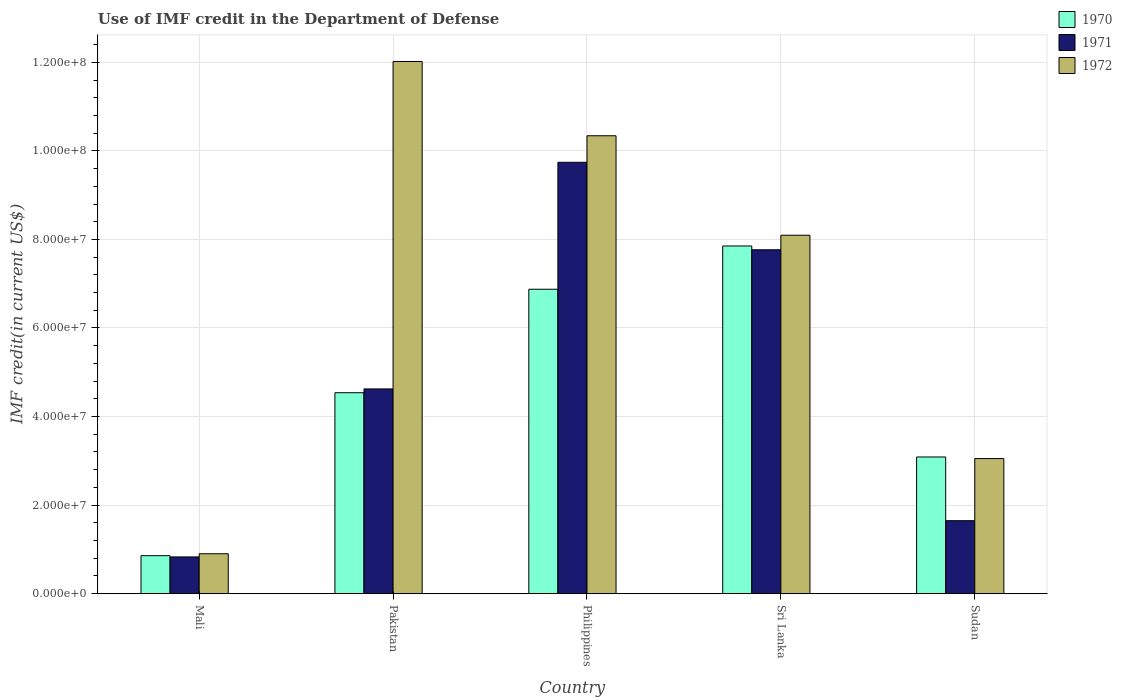How many different coloured bars are there?
Keep it short and to the point. 3. How many groups of bars are there?
Provide a short and direct response. 5. Are the number of bars per tick equal to the number of legend labels?
Provide a succinct answer. Yes. Are the number of bars on each tick of the X-axis equal?
Your response must be concise. Yes. How many bars are there on the 5th tick from the left?
Your answer should be very brief. 3. What is the label of the 2nd group of bars from the left?
Offer a terse response. Pakistan. What is the IMF credit in the Department of Defense in 1971 in Pakistan?
Provide a short and direct response. 4.62e+07. Across all countries, what is the maximum IMF credit in the Department of Defense in 1971?
Your response must be concise. 9.74e+07. Across all countries, what is the minimum IMF credit in the Department of Defense in 1971?
Offer a terse response. 8.30e+06. In which country was the IMF credit in the Department of Defense in 1970 maximum?
Your answer should be very brief. Sri Lanka. In which country was the IMF credit in the Department of Defense in 1971 minimum?
Offer a very short reply. Mali. What is the total IMF credit in the Department of Defense in 1971 in the graph?
Your answer should be compact. 2.46e+08. What is the difference between the IMF credit in the Department of Defense in 1972 in Mali and that in Sri Lanka?
Give a very brief answer. -7.19e+07. What is the difference between the IMF credit in the Department of Defense in 1971 in Sri Lanka and the IMF credit in the Department of Defense in 1972 in Mali?
Your answer should be very brief. 6.87e+07. What is the average IMF credit in the Department of Defense in 1971 per country?
Keep it short and to the point. 4.92e+07. What is the difference between the IMF credit in the Department of Defense of/in 1971 and IMF credit in the Department of Defense of/in 1970 in Sri Lanka?
Offer a very short reply. -8.56e+05. What is the ratio of the IMF credit in the Department of Defense in 1971 in Pakistan to that in Sri Lanka?
Your response must be concise. 0.6. Is the difference between the IMF credit in the Department of Defense in 1971 in Mali and Philippines greater than the difference between the IMF credit in the Department of Defense in 1970 in Mali and Philippines?
Offer a terse response. No. What is the difference between the highest and the second highest IMF credit in the Department of Defense in 1972?
Your answer should be compact. 1.68e+07. What is the difference between the highest and the lowest IMF credit in the Department of Defense in 1970?
Your answer should be very brief. 6.99e+07. In how many countries, is the IMF credit in the Department of Defense in 1971 greater than the average IMF credit in the Department of Defense in 1971 taken over all countries?
Your answer should be compact. 2. Is the sum of the IMF credit in the Department of Defense in 1970 in Mali and Philippines greater than the maximum IMF credit in the Department of Defense in 1972 across all countries?
Give a very brief answer. No. Is it the case that in every country, the sum of the IMF credit in the Department of Defense in 1970 and IMF credit in the Department of Defense in 1971 is greater than the IMF credit in the Department of Defense in 1972?
Offer a terse response. No. Are all the bars in the graph horizontal?
Give a very brief answer. No. How many countries are there in the graph?
Your answer should be very brief. 5. Does the graph contain any zero values?
Make the answer very short. No. Does the graph contain grids?
Make the answer very short. Yes. How many legend labels are there?
Your answer should be very brief. 3. How are the legend labels stacked?
Your response must be concise. Vertical. What is the title of the graph?
Keep it short and to the point. Use of IMF credit in the Department of Defense. What is the label or title of the X-axis?
Ensure brevity in your answer.  Country. What is the label or title of the Y-axis?
Your answer should be compact. IMF credit(in current US$). What is the IMF credit(in current US$) of 1970 in Mali?
Your response must be concise. 8.58e+06. What is the IMF credit(in current US$) in 1971 in Mali?
Give a very brief answer. 8.30e+06. What is the IMF credit(in current US$) in 1972 in Mali?
Provide a short and direct response. 9.01e+06. What is the IMF credit(in current US$) of 1970 in Pakistan?
Provide a succinct answer. 4.54e+07. What is the IMF credit(in current US$) of 1971 in Pakistan?
Your response must be concise. 4.62e+07. What is the IMF credit(in current US$) in 1972 in Pakistan?
Provide a succinct answer. 1.20e+08. What is the IMF credit(in current US$) in 1970 in Philippines?
Provide a short and direct response. 6.88e+07. What is the IMF credit(in current US$) of 1971 in Philippines?
Make the answer very short. 9.74e+07. What is the IMF credit(in current US$) of 1972 in Philippines?
Ensure brevity in your answer.  1.03e+08. What is the IMF credit(in current US$) of 1970 in Sri Lanka?
Make the answer very short. 7.85e+07. What is the IMF credit(in current US$) of 1971 in Sri Lanka?
Provide a short and direct response. 7.77e+07. What is the IMF credit(in current US$) in 1972 in Sri Lanka?
Offer a very short reply. 8.10e+07. What is the IMF credit(in current US$) in 1970 in Sudan?
Provide a succinct answer. 3.09e+07. What is the IMF credit(in current US$) in 1971 in Sudan?
Provide a short and direct response. 1.65e+07. What is the IMF credit(in current US$) in 1972 in Sudan?
Offer a very short reply. 3.05e+07. Across all countries, what is the maximum IMF credit(in current US$) of 1970?
Your response must be concise. 7.85e+07. Across all countries, what is the maximum IMF credit(in current US$) of 1971?
Your answer should be compact. 9.74e+07. Across all countries, what is the maximum IMF credit(in current US$) of 1972?
Provide a short and direct response. 1.20e+08. Across all countries, what is the minimum IMF credit(in current US$) in 1970?
Provide a short and direct response. 8.58e+06. Across all countries, what is the minimum IMF credit(in current US$) of 1971?
Your response must be concise. 8.30e+06. Across all countries, what is the minimum IMF credit(in current US$) in 1972?
Provide a short and direct response. 9.01e+06. What is the total IMF credit(in current US$) of 1970 in the graph?
Make the answer very short. 2.32e+08. What is the total IMF credit(in current US$) of 1971 in the graph?
Your answer should be compact. 2.46e+08. What is the total IMF credit(in current US$) of 1972 in the graph?
Offer a very short reply. 3.44e+08. What is the difference between the IMF credit(in current US$) in 1970 in Mali and that in Pakistan?
Provide a short and direct response. -3.68e+07. What is the difference between the IMF credit(in current US$) of 1971 in Mali and that in Pakistan?
Your answer should be very brief. -3.79e+07. What is the difference between the IMF credit(in current US$) of 1972 in Mali and that in Pakistan?
Keep it short and to the point. -1.11e+08. What is the difference between the IMF credit(in current US$) of 1970 in Mali and that in Philippines?
Keep it short and to the point. -6.02e+07. What is the difference between the IMF credit(in current US$) in 1971 in Mali and that in Philippines?
Your answer should be compact. -8.91e+07. What is the difference between the IMF credit(in current US$) in 1972 in Mali and that in Philippines?
Offer a terse response. -9.44e+07. What is the difference between the IMF credit(in current US$) in 1970 in Mali and that in Sri Lanka?
Your answer should be compact. -6.99e+07. What is the difference between the IMF credit(in current US$) in 1971 in Mali and that in Sri Lanka?
Offer a terse response. -6.94e+07. What is the difference between the IMF credit(in current US$) of 1972 in Mali and that in Sri Lanka?
Keep it short and to the point. -7.19e+07. What is the difference between the IMF credit(in current US$) in 1970 in Mali and that in Sudan?
Keep it short and to the point. -2.23e+07. What is the difference between the IMF credit(in current US$) in 1971 in Mali and that in Sudan?
Keep it short and to the point. -8.19e+06. What is the difference between the IMF credit(in current US$) in 1972 in Mali and that in Sudan?
Your answer should be compact. -2.15e+07. What is the difference between the IMF credit(in current US$) in 1970 in Pakistan and that in Philippines?
Your answer should be very brief. -2.34e+07. What is the difference between the IMF credit(in current US$) in 1971 in Pakistan and that in Philippines?
Give a very brief answer. -5.12e+07. What is the difference between the IMF credit(in current US$) of 1972 in Pakistan and that in Philippines?
Your answer should be very brief. 1.68e+07. What is the difference between the IMF credit(in current US$) of 1970 in Pakistan and that in Sri Lanka?
Ensure brevity in your answer.  -3.31e+07. What is the difference between the IMF credit(in current US$) in 1971 in Pakistan and that in Sri Lanka?
Provide a short and direct response. -3.14e+07. What is the difference between the IMF credit(in current US$) of 1972 in Pakistan and that in Sri Lanka?
Make the answer very short. 3.92e+07. What is the difference between the IMF credit(in current US$) in 1970 in Pakistan and that in Sudan?
Provide a succinct answer. 1.45e+07. What is the difference between the IMF credit(in current US$) of 1971 in Pakistan and that in Sudan?
Ensure brevity in your answer.  2.98e+07. What is the difference between the IMF credit(in current US$) in 1972 in Pakistan and that in Sudan?
Provide a short and direct response. 8.97e+07. What is the difference between the IMF credit(in current US$) in 1970 in Philippines and that in Sri Lanka?
Provide a succinct answer. -9.77e+06. What is the difference between the IMF credit(in current US$) in 1971 in Philippines and that in Sri Lanka?
Make the answer very short. 1.98e+07. What is the difference between the IMF credit(in current US$) in 1972 in Philippines and that in Sri Lanka?
Make the answer very short. 2.25e+07. What is the difference between the IMF credit(in current US$) of 1970 in Philippines and that in Sudan?
Provide a short and direct response. 3.79e+07. What is the difference between the IMF credit(in current US$) of 1971 in Philippines and that in Sudan?
Ensure brevity in your answer.  8.09e+07. What is the difference between the IMF credit(in current US$) of 1972 in Philippines and that in Sudan?
Offer a terse response. 7.29e+07. What is the difference between the IMF credit(in current US$) of 1970 in Sri Lanka and that in Sudan?
Your answer should be very brief. 4.76e+07. What is the difference between the IMF credit(in current US$) in 1971 in Sri Lanka and that in Sudan?
Your answer should be very brief. 6.12e+07. What is the difference between the IMF credit(in current US$) of 1972 in Sri Lanka and that in Sudan?
Offer a very short reply. 5.04e+07. What is the difference between the IMF credit(in current US$) of 1970 in Mali and the IMF credit(in current US$) of 1971 in Pakistan?
Provide a short and direct response. -3.77e+07. What is the difference between the IMF credit(in current US$) of 1970 in Mali and the IMF credit(in current US$) of 1972 in Pakistan?
Your answer should be very brief. -1.12e+08. What is the difference between the IMF credit(in current US$) of 1971 in Mali and the IMF credit(in current US$) of 1972 in Pakistan?
Make the answer very short. -1.12e+08. What is the difference between the IMF credit(in current US$) in 1970 in Mali and the IMF credit(in current US$) in 1971 in Philippines?
Your answer should be compact. -8.88e+07. What is the difference between the IMF credit(in current US$) in 1970 in Mali and the IMF credit(in current US$) in 1972 in Philippines?
Your answer should be compact. -9.48e+07. What is the difference between the IMF credit(in current US$) of 1971 in Mali and the IMF credit(in current US$) of 1972 in Philippines?
Your response must be concise. -9.51e+07. What is the difference between the IMF credit(in current US$) in 1970 in Mali and the IMF credit(in current US$) in 1971 in Sri Lanka?
Provide a short and direct response. -6.91e+07. What is the difference between the IMF credit(in current US$) in 1970 in Mali and the IMF credit(in current US$) in 1972 in Sri Lanka?
Your answer should be very brief. -7.24e+07. What is the difference between the IMF credit(in current US$) of 1971 in Mali and the IMF credit(in current US$) of 1972 in Sri Lanka?
Provide a short and direct response. -7.27e+07. What is the difference between the IMF credit(in current US$) in 1970 in Mali and the IMF credit(in current US$) in 1971 in Sudan?
Your answer should be compact. -7.90e+06. What is the difference between the IMF credit(in current US$) in 1970 in Mali and the IMF credit(in current US$) in 1972 in Sudan?
Your answer should be compact. -2.19e+07. What is the difference between the IMF credit(in current US$) of 1971 in Mali and the IMF credit(in current US$) of 1972 in Sudan?
Make the answer very short. -2.22e+07. What is the difference between the IMF credit(in current US$) in 1970 in Pakistan and the IMF credit(in current US$) in 1971 in Philippines?
Your answer should be compact. -5.20e+07. What is the difference between the IMF credit(in current US$) of 1970 in Pakistan and the IMF credit(in current US$) of 1972 in Philippines?
Keep it short and to the point. -5.80e+07. What is the difference between the IMF credit(in current US$) of 1971 in Pakistan and the IMF credit(in current US$) of 1972 in Philippines?
Give a very brief answer. -5.72e+07. What is the difference between the IMF credit(in current US$) in 1970 in Pakistan and the IMF credit(in current US$) in 1971 in Sri Lanka?
Keep it short and to the point. -3.23e+07. What is the difference between the IMF credit(in current US$) in 1970 in Pakistan and the IMF credit(in current US$) in 1972 in Sri Lanka?
Your answer should be compact. -3.56e+07. What is the difference between the IMF credit(in current US$) of 1971 in Pakistan and the IMF credit(in current US$) of 1972 in Sri Lanka?
Offer a terse response. -3.47e+07. What is the difference between the IMF credit(in current US$) in 1970 in Pakistan and the IMF credit(in current US$) in 1971 in Sudan?
Your answer should be compact. 2.89e+07. What is the difference between the IMF credit(in current US$) in 1970 in Pakistan and the IMF credit(in current US$) in 1972 in Sudan?
Your answer should be very brief. 1.49e+07. What is the difference between the IMF credit(in current US$) in 1971 in Pakistan and the IMF credit(in current US$) in 1972 in Sudan?
Offer a terse response. 1.57e+07. What is the difference between the IMF credit(in current US$) of 1970 in Philippines and the IMF credit(in current US$) of 1971 in Sri Lanka?
Your answer should be very brief. -8.91e+06. What is the difference between the IMF credit(in current US$) in 1970 in Philippines and the IMF credit(in current US$) in 1972 in Sri Lanka?
Make the answer very short. -1.22e+07. What is the difference between the IMF credit(in current US$) of 1971 in Philippines and the IMF credit(in current US$) of 1972 in Sri Lanka?
Keep it short and to the point. 1.65e+07. What is the difference between the IMF credit(in current US$) in 1970 in Philippines and the IMF credit(in current US$) in 1971 in Sudan?
Your response must be concise. 5.23e+07. What is the difference between the IMF credit(in current US$) of 1970 in Philippines and the IMF credit(in current US$) of 1972 in Sudan?
Your response must be concise. 3.82e+07. What is the difference between the IMF credit(in current US$) in 1971 in Philippines and the IMF credit(in current US$) in 1972 in Sudan?
Your answer should be compact. 6.69e+07. What is the difference between the IMF credit(in current US$) in 1970 in Sri Lanka and the IMF credit(in current US$) in 1971 in Sudan?
Offer a terse response. 6.20e+07. What is the difference between the IMF credit(in current US$) of 1970 in Sri Lanka and the IMF credit(in current US$) of 1972 in Sudan?
Provide a succinct answer. 4.80e+07. What is the difference between the IMF credit(in current US$) of 1971 in Sri Lanka and the IMF credit(in current US$) of 1972 in Sudan?
Provide a succinct answer. 4.72e+07. What is the average IMF credit(in current US$) of 1970 per country?
Keep it short and to the point. 4.64e+07. What is the average IMF credit(in current US$) of 1971 per country?
Your answer should be very brief. 4.92e+07. What is the average IMF credit(in current US$) in 1972 per country?
Provide a succinct answer. 6.88e+07. What is the difference between the IMF credit(in current US$) of 1970 and IMF credit(in current US$) of 1971 in Mali?
Give a very brief answer. 2.85e+05. What is the difference between the IMF credit(in current US$) of 1970 and IMF credit(in current US$) of 1972 in Mali?
Your response must be concise. -4.31e+05. What is the difference between the IMF credit(in current US$) of 1971 and IMF credit(in current US$) of 1972 in Mali?
Your response must be concise. -7.16e+05. What is the difference between the IMF credit(in current US$) in 1970 and IMF credit(in current US$) in 1971 in Pakistan?
Give a very brief answer. -8.56e+05. What is the difference between the IMF credit(in current US$) in 1970 and IMF credit(in current US$) in 1972 in Pakistan?
Keep it short and to the point. -7.48e+07. What is the difference between the IMF credit(in current US$) in 1971 and IMF credit(in current US$) in 1972 in Pakistan?
Give a very brief answer. -7.40e+07. What is the difference between the IMF credit(in current US$) of 1970 and IMF credit(in current US$) of 1971 in Philippines?
Offer a very short reply. -2.87e+07. What is the difference between the IMF credit(in current US$) of 1970 and IMF credit(in current US$) of 1972 in Philippines?
Offer a very short reply. -3.47e+07. What is the difference between the IMF credit(in current US$) in 1971 and IMF credit(in current US$) in 1972 in Philippines?
Your answer should be compact. -5.99e+06. What is the difference between the IMF credit(in current US$) of 1970 and IMF credit(in current US$) of 1971 in Sri Lanka?
Your answer should be very brief. 8.56e+05. What is the difference between the IMF credit(in current US$) of 1970 and IMF credit(in current US$) of 1972 in Sri Lanka?
Your answer should be compact. -2.43e+06. What is the difference between the IMF credit(in current US$) of 1971 and IMF credit(in current US$) of 1972 in Sri Lanka?
Offer a very short reply. -3.29e+06. What is the difference between the IMF credit(in current US$) in 1970 and IMF credit(in current US$) in 1971 in Sudan?
Provide a short and direct response. 1.44e+07. What is the difference between the IMF credit(in current US$) in 1970 and IMF credit(in current US$) in 1972 in Sudan?
Keep it short and to the point. 3.62e+05. What is the difference between the IMF credit(in current US$) of 1971 and IMF credit(in current US$) of 1972 in Sudan?
Offer a very short reply. -1.40e+07. What is the ratio of the IMF credit(in current US$) of 1970 in Mali to that in Pakistan?
Make the answer very short. 0.19. What is the ratio of the IMF credit(in current US$) of 1971 in Mali to that in Pakistan?
Offer a very short reply. 0.18. What is the ratio of the IMF credit(in current US$) in 1972 in Mali to that in Pakistan?
Your answer should be very brief. 0.07. What is the ratio of the IMF credit(in current US$) in 1970 in Mali to that in Philippines?
Offer a terse response. 0.12. What is the ratio of the IMF credit(in current US$) of 1971 in Mali to that in Philippines?
Make the answer very short. 0.09. What is the ratio of the IMF credit(in current US$) in 1972 in Mali to that in Philippines?
Make the answer very short. 0.09. What is the ratio of the IMF credit(in current US$) of 1970 in Mali to that in Sri Lanka?
Ensure brevity in your answer.  0.11. What is the ratio of the IMF credit(in current US$) of 1971 in Mali to that in Sri Lanka?
Provide a short and direct response. 0.11. What is the ratio of the IMF credit(in current US$) of 1972 in Mali to that in Sri Lanka?
Give a very brief answer. 0.11. What is the ratio of the IMF credit(in current US$) of 1970 in Mali to that in Sudan?
Give a very brief answer. 0.28. What is the ratio of the IMF credit(in current US$) of 1971 in Mali to that in Sudan?
Your answer should be very brief. 0.5. What is the ratio of the IMF credit(in current US$) of 1972 in Mali to that in Sudan?
Ensure brevity in your answer.  0.3. What is the ratio of the IMF credit(in current US$) of 1970 in Pakistan to that in Philippines?
Offer a very short reply. 0.66. What is the ratio of the IMF credit(in current US$) of 1971 in Pakistan to that in Philippines?
Ensure brevity in your answer.  0.47. What is the ratio of the IMF credit(in current US$) of 1972 in Pakistan to that in Philippines?
Ensure brevity in your answer.  1.16. What is the ratio of the IMF credit(in current US$) of 1970 in Pakistan to that in Sri Lanka?
Make the answer very short. 0.58. What is the ratio of the IMF credit(in current US$) in 1971 in Pakistan to that in Sri Lanka?
Give a very brief answer. 0.6. What is the ratio of the IMF credit(in current US$) of 1972 in Pakistan to that in Sri Lanka?
Offer a terse response. 1.48. What is the ratio of the IMF credit(in current US$) in 1970 in Pakistan to that in Sudan?
Provide a short and direct response. 1.47. What is the ratio of the IMF credit(in current US$) of 1971 in Pakistan to that in Sudan?
Ensure brevity in your answer.  2.81. What is the ratio of the IMF credit(in current US$) in 1972 in Pakistan to that in Sudan?
Provide a short and direct response. 3.94. What is the ratio of the IMF credit(in current US$) in 1970 in Philippines to that in Sri Lanka?
Give a very brief answer. 0.88. What is the ratio of the IMF credit(in current US$) of 1971 in Philippines to that in Sri Lanka?
Your answer should be compact. 1.25. What is the ratio of the IMF credit(in current US$) of 1972 in Philippines to that in Sri Lanka?
Your response must be concise. 1.28. What is the ratio of the IMF credit(in current US$) of 1970 in Philippines to that in Sudan?
Your answer should be very brief. 2.23. What is the ratio of the IMF credit(in current US$) of 1971 in Philippines to that in Sudan?
Ensure brevity in your answer.  5.91. What is the ratio of the IMF credit(in current US$) in 1972 in Philippines to that in Sudan?
Offer a terse response. 3.39. What is the ratio of the IMF credit(in current US$) in 1970 in Sri Lanka to that in Sudan?
Your answer should be compact. 2.54. What is the ratio of the IMF credit(in current US$) in 1971 in Sri Lanka to that in Sudan?
Ensure brevity in your answer.  4.71. What is the ratio of the IMF credit(in current US$) in 1972 in Sri Lanka to that in Sudan?
Your response must be concise. 2.65. What is the difference between the highest and the second highest IMF credit(in current US$) of 1970?
Your answer should be compact. 9.77e+06. What is the difference between the highest and the second highest IMF credit(in current US$) in 1971?
Give a very brief answer. 1.98e+07. What is the difference between the highest and the second highest IMF credit(in current US$) of 1972?
Your answer should be compact. 1.68e+07. What is the difference between the highest and the lowest IMF credit(in current US$) of 1970?
Keep it short and to the point. 6.99e+07. What is the difference between the highest and the lowest IMF credit(in current US$) of 1971?
Offer a terse response. 8.91e+07. What is the difference between the highest and the lowest IMF credit(in current US$) of 1972?
Ensure brevity in your answer.  1.11e+08. 